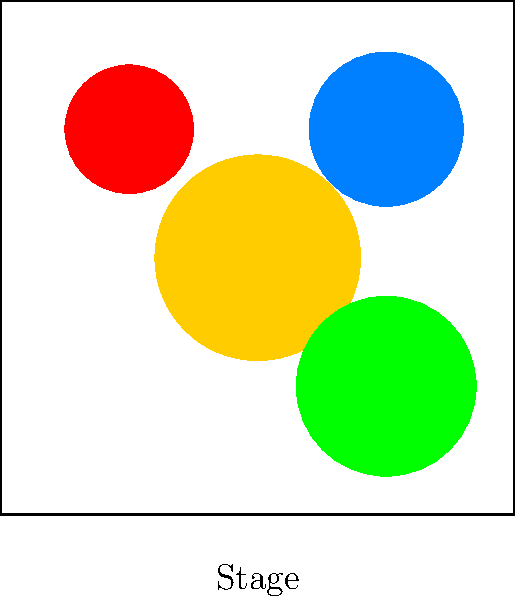In the stage lighting diagram, which color combination would most effectively create a sense of conflict and tension for a dramatic confrontation scene? To determine the most effective color combination for creating conflict and tension in a dramatic confrontation scene, let's analyze the emotional effects of each color:

1. Warm amber (center): Creates a sense of comfort and warmth.
2. Cool blue (top right): Evokes calmness and serenity.
3. Intense red (top left): Symbolizes passion, anger, and intensity.
4. Soft green (bottom right): Represents nature, growth, and harmony.

For a dramatic confrontation scene, we want to create tension and conflict. The most effective combination would be:

1. Intense red: This color immediately creates a sense of danger, anger, and high emotions.
2. Cool blue: When used in contrast with the intense red, it creates a visual and emotional conflict, representing opposing forces or viewpoints.

The combination of intense red and cool blue creates a strong visual contrast that mirrors the emotional conflict in the scene. The red light can be used to highlight the more aggressive or passionate character, while the blue light can emphasize the calmer or more reserved character, creating a visual representation of their emotional states and the tension between them.

The warm amber and soft green lights, while useful in other contexts, would not contribute as effectively to the sense of conflict and tension required for this particular scene.
Answer: Intense red and cool blue 